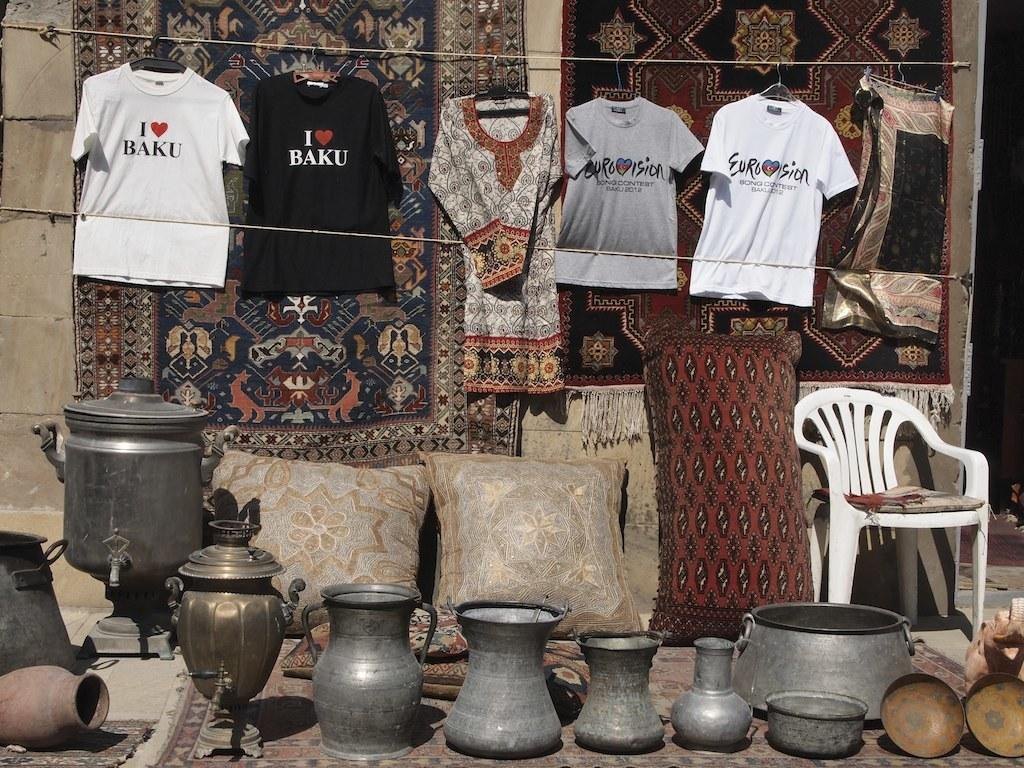<image>
Write a terse but informative summary of the picture. Metal vases, pillows, and t-shirts saying I LOVE BAKU and Eurovision hang for sale. 